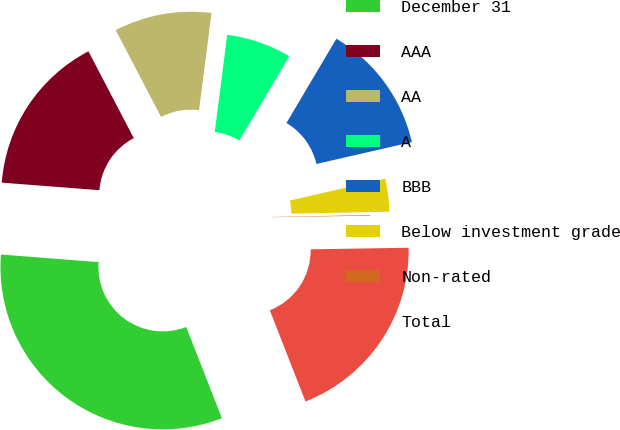Convert chart to OTSL. <chart><loc_0><loc_0><loc_500><loc_500><pie_chart><fcel>December 31<fcel>AAA<fcel>AA<fcel>A<fcel>BBB<fcel>Below investment grade<fcel>Non-rated<fcel>Total<nl><fcel>32.16%<fcel>16.11%<fcel>9.69%<fcel>6.48%<fcel>12.9%<fcel>3.27%<fcel>0.06%<fcel>19.32%<nl></chart> 